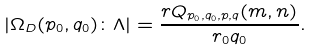Convert formula to latex. <formula><loc_0><loc_0><loc_500><loc_500>\left | \Omega _ { D } ( p _ { 0 } , q _ { 0 } ) \colon \Lambda \right | = \frac { r Q _ { p _ { 0 } , q _ { 0 } , p , q } ( m , n ) } { r _ { 0 } q _ { 0 } } .</formula> 